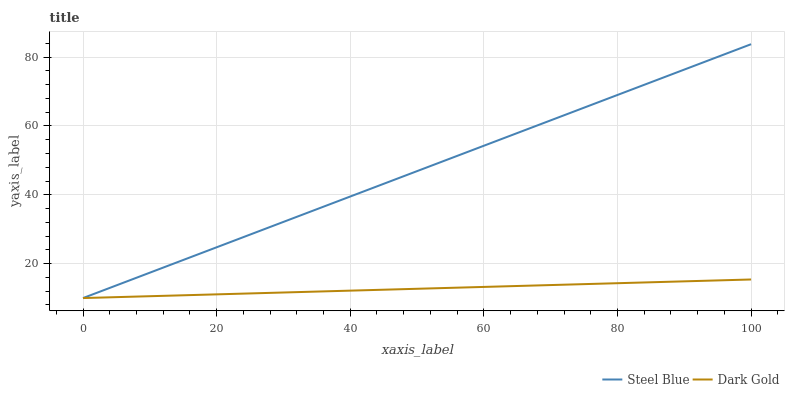Does Dark Gold have the minimum area under the curve?
Answer yes or no. Yes. Does Steel Blue have the maximum area under the curve?
Answer yes or no. Yes. Does Dark Gold have the maximum area under the curve?
Answer yes or no. No. Is Dark Gold the smoothest?
Answer yes or no. Yes. Is Steel Blue the roughest?
Answer yes or no. Yes. Is Dark Gold the roughest?
Answer yes or no. No. Does Steel Blue have the lowest value?
Answer yes or no. Yes. Does Steel Blue have the highest value?
Answer yes or no. Yes. Does Dark Gold have the highest value?
Answer yes or no. No. Does Dark Gold intersect Steel Blue?
Answer yes or no. Yes. Is Dark Gold less than Steel Blue?
Answer yes or no. No. Is Dark Gold greater than Steel Blue?
Answer yes or no. No. 